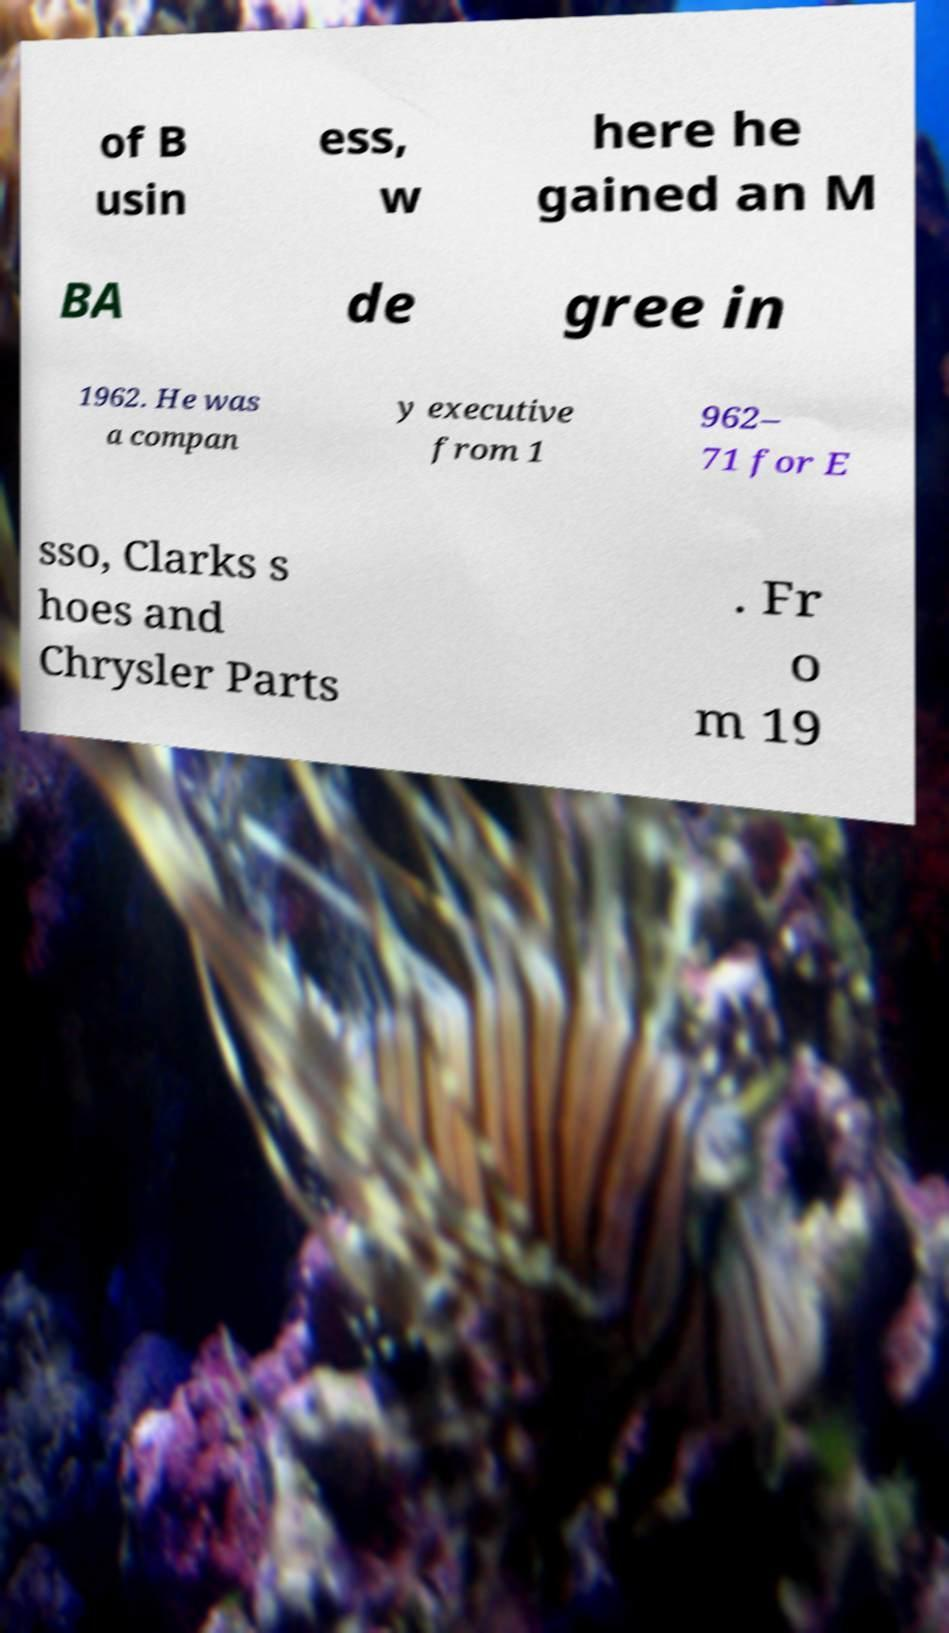I need the written content from this picture converted into text. Can you do that? of B usin ess, w here he gained an M BA de gree in 1962. He was a compan y executive from 1 962– 71 for E sso, Clarks s hoes and Chrysler Parts . Fr o m 19 